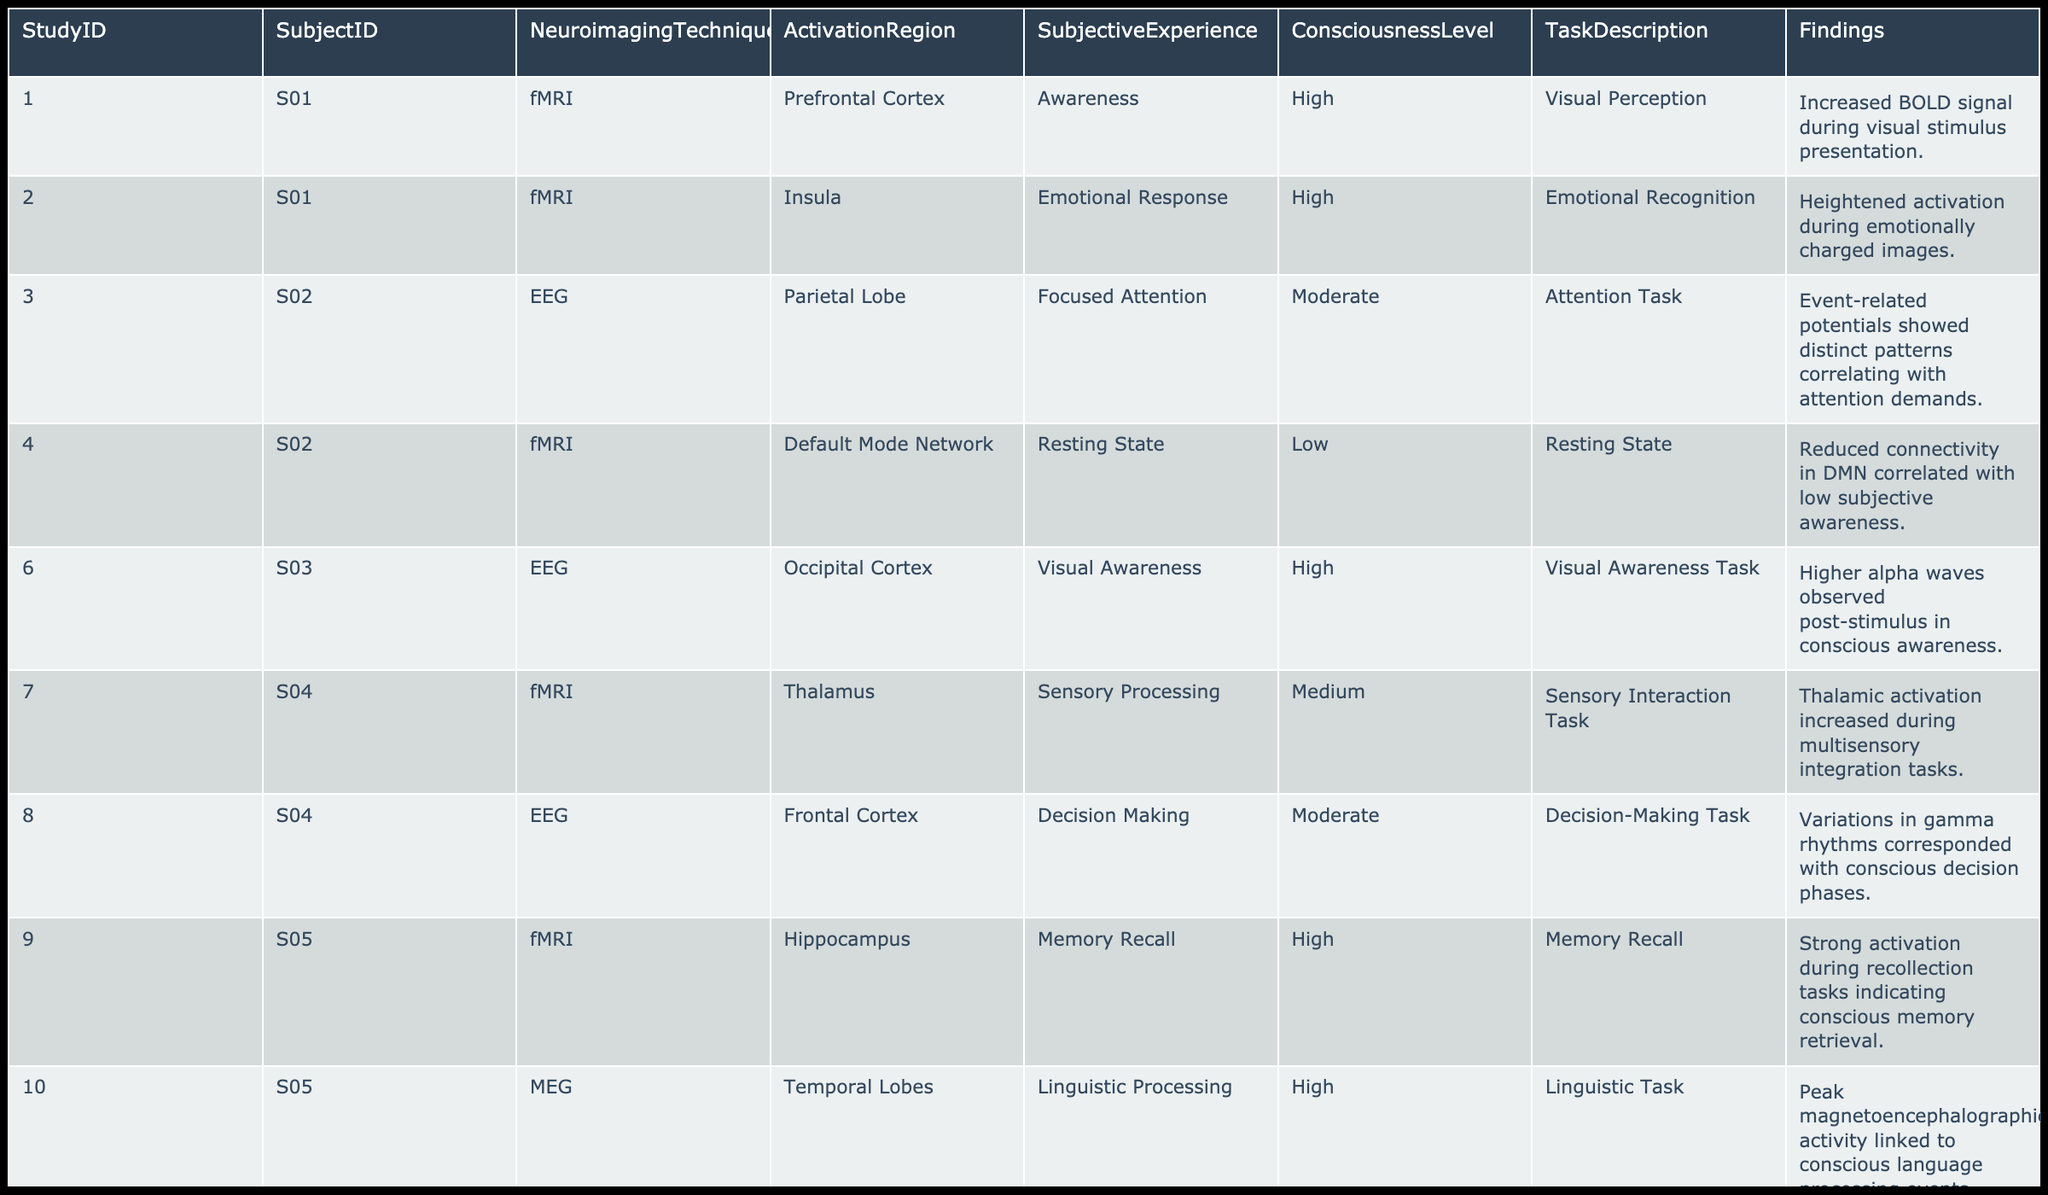What neuroimaging technique was used in Study ID 3? The table shows that Study ID 3 utilized EEG as the neuroimaging technique.
Answer: EEG Which activation region is associated with the highest level of consciousness in Study ID 9? In Study ID 9, the activation region associated with the highest level of consciousness is the Hippocampus.
Answer: Hippocampus How many subjects reported emotional awareness during their tasks? By examining the table, we see that there are 2 subjects (S07) who reported emotional awareness associated with the Amygdala activation.
Answer: 2 Is there a correlation between high consciousness levels and fMRI usage in the studies? Yes, all studies with high consciousness levels (Study IDs 1, 2, 9, 10, 11, 13, and 14) used fMRI, which shows a clear correlation.
Answer: Yes What is the average consciousness level of the tasks reported in the dataset? The total consciousness levels are High (5), Medium (3), and Low (2) which translates to values of 3, 2, and 1 respectively. Therefore, the average value is calculated as: (5*3 + 3*2 + 2*1) / 10 = (15 + 6 + 2) / 10 = 23 / 10 = 2.3.
Answer: 2.3 